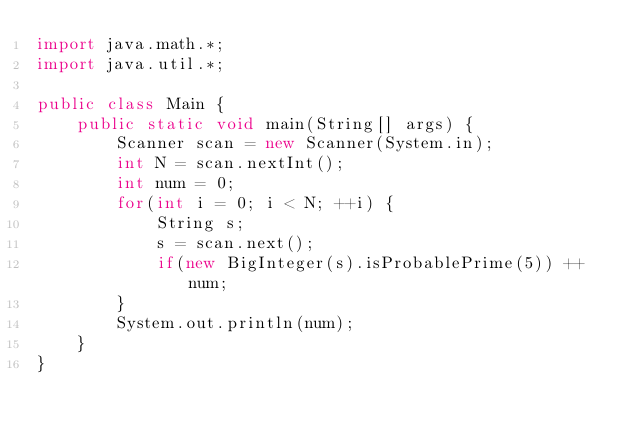<code> <loc_0><loc_0><loc_500><loc_500><_Java_>import java.math.*;
import java.util.*;

public class Main {
    public static void main(String[] args) {
        Scanner scan = new Scanner(System.in);
        int N = scan.nextInt();
        int num = 0;
        for(int i = 0; i < N; ++i) {
            String s;
            s = scan.next();
            if(new BigInteger(s).isProbablePrime(5)) ++num;
        }
        System.out.println(num);
    }
}</code> 